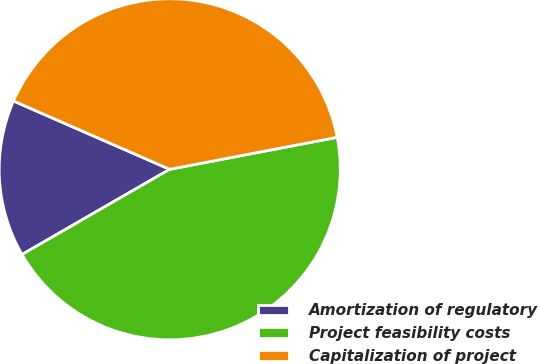Convert chart. <chart><loc_0><loc_0><loc_500><loc_500><pie_chart><fcel>Amortization of regulatory<fcel>Project feasibility costs<fcel>Capitalization of project<nl><fcel>14.89%<fcel>44.68%<fcel>40.43%<nl></chart> 